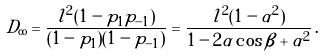<formula> <loc_0><loc_0><loc_500><loc_500>D _ { \infty } = \frac { l ^ { 2 } ( 1 - p _ { 1 } p _ { - 1 } ) } { ( 1 - p _ { 1 } ) ( 1 - p _ { - 1 } ) } = \frac { l ^ { 2 } ( 1 - \alpha ^ { 2 } ) } { 1 - 2 \alpha \cos \beta + \alpha ^ { 2 } } \, .</formula> 